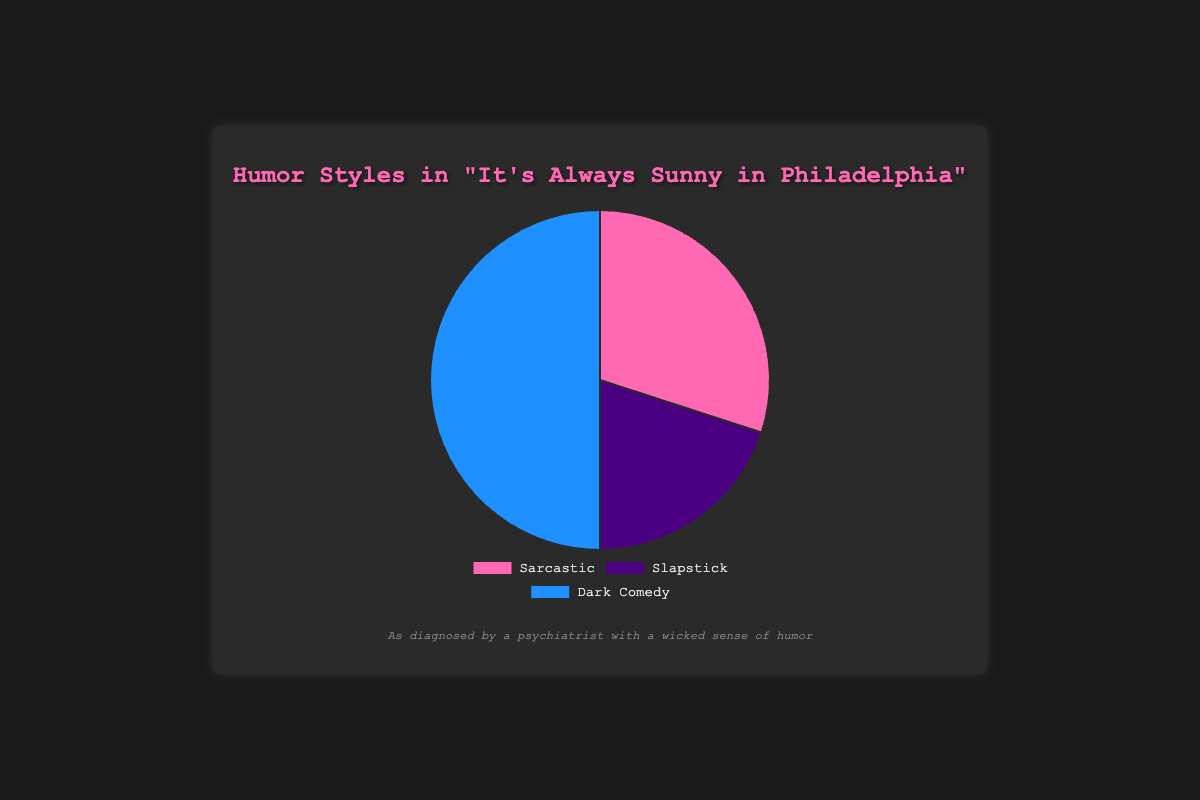What is the dominant humor style in "It's Always Sunny in Philadelphia"? The pie chart shows that the majority of the chart is blue, representing Dark Comedy. By comparing the sizes of each section, we can see that Dark Comedy occupies the largest portion of the chart.
Answer: Dark Comedy Which humor style is least represented in "It's Always Sunny in Philadelphia"? The pie chart shows the smallest section is the purple one, representing Slapstick. Identifying the smallest segment gives us our answer.
Answer: Slapstick What is the combined percentage of Sarcastic and Slapstick in "It's Always Sunny in Philadelphia"? The chart shows 30% for Sarcastic and 20% for Slapstick. Adding these two percentages together (30 + 20) gives us the total percentage.
Answer: 50% Is the percentage of Dark Comedy greater than the combined percentage of Sarcastic and Slapstick? The pie chart shows Dark Comedy at 50% and the combination of Sarcastic (30%) and Slapstick (20%) is also 50%. Therefore, Dark Comedy is not greater than their combined percentage but is equal.
Answer: No Which humor style in "It's Always Sunny in Philadelphia" has nearly half of the total representation? By examining the pie chart, we see the blue section representing Dark Comedy occupies half of the chart, indicating around 50%.
Answer: Dark Comedy What is the difference in percentage between Dark Comedy and Slapstick in "It's Always Sunny in Philadelphia"? The chart shows Dark Comedy at 50% and Slapstick at 20%. Subtracting these percentages (50 - 20) gives us the difference.
Answer: 30% Rank the humor styles in "It's Always Sunny in Philadelphia" from highest to lowest percentage. The pie chart shows: Dark Comedy (50%), Sarcastic (30%), and Slapstick (20%). Therefore, the order from highest to lowest is Dark Comedy, Sarcastic, and Slapstick.
Answer: Dark Comedy, Sarcastic, Slapstick How much more Sarcastic humor is there compared to Slapstick humor in "It's Always Sunny in Philadelphia"? The chart shows Sarcastic at 30% and Slapstick at 20%. Subtracting these values (30 - 20) gives the extra percentage of Sarcastic humor.
Answer: 10% What percentage of the humor styles in "It's Always Sunny in Philadelphia" are not Sarcastic? Sarcastic humor occupies 30% of the pie chart. The remaining percentage (100 - 30) accounts for humor styles that are not Sarcastic.
Answer: 70% 